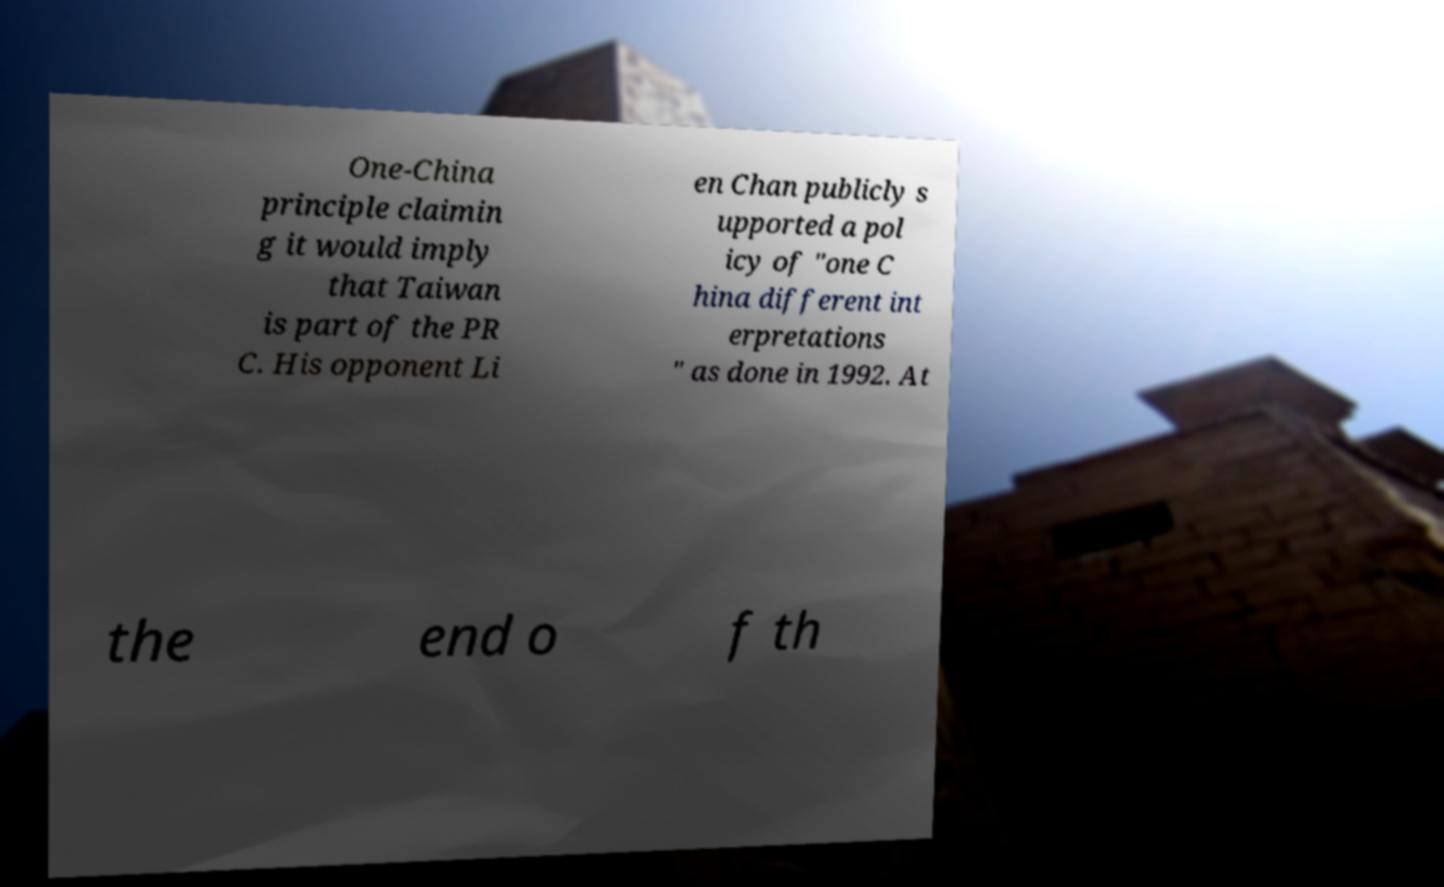Can you accurately transcribe the text from the provided image for me? One-China principle claimin g it would imply that Taiwan is part of the PR C. His opponent Li en Chan publicly s upported a pol icy of "one C hina different int erpretations " as done in 1992. At the end o f th 